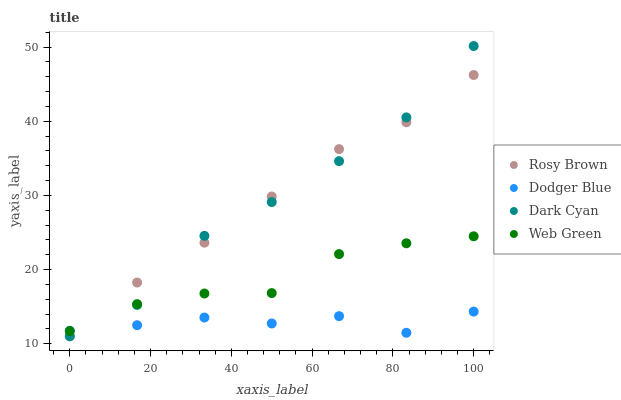Does Dodger Blue have the minimum area under the curve?
Answer yes or no. Yes. Does Rosy Brown have the maximum area under the curve?
Answer yes or no. Yes. Does Rosy Brown have the minimum area under the curve?
Answer yes or no. No. Does Dodger Blue have the maximum area under the curve?
Answer yes or no. No. Is Rosy Brown the smoothest?
Answer yes or no. Yes. Is Dark Cyan the roughest?
Answer yes or no. Yes. Is Dodger Blue the smoothest?
Answer yes or no. No. Is Dodger Blue the roughest?
Answer yes or no. No. Does Dark Cyan have the lowest value?
Answer yes or no. Yes. Does Dodger Blue have the lowest value?
Answer yes or no. No. Does Dark Cyan have the highest value?
Answer yes or no. Yes. Does Rosy Brown have the highest value?
Answer yes or no. No. Does Dark Cyan intersect Web Green?
Answer yes or no. Yes. Is Dark Cyan less than Web Green?
Answer yes or no. No. Is Dark Cyan greater than Web Green?
Answer yes or no. No. 